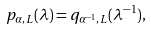<formula> <loc_0><loc_0><loc_500><loc_500>p _ { \alpha , L } ( \lambda ) = q _ { \alpha ^ { - 1 } , L } ( \lambda ^ { - 1 } ) ,</formula> 